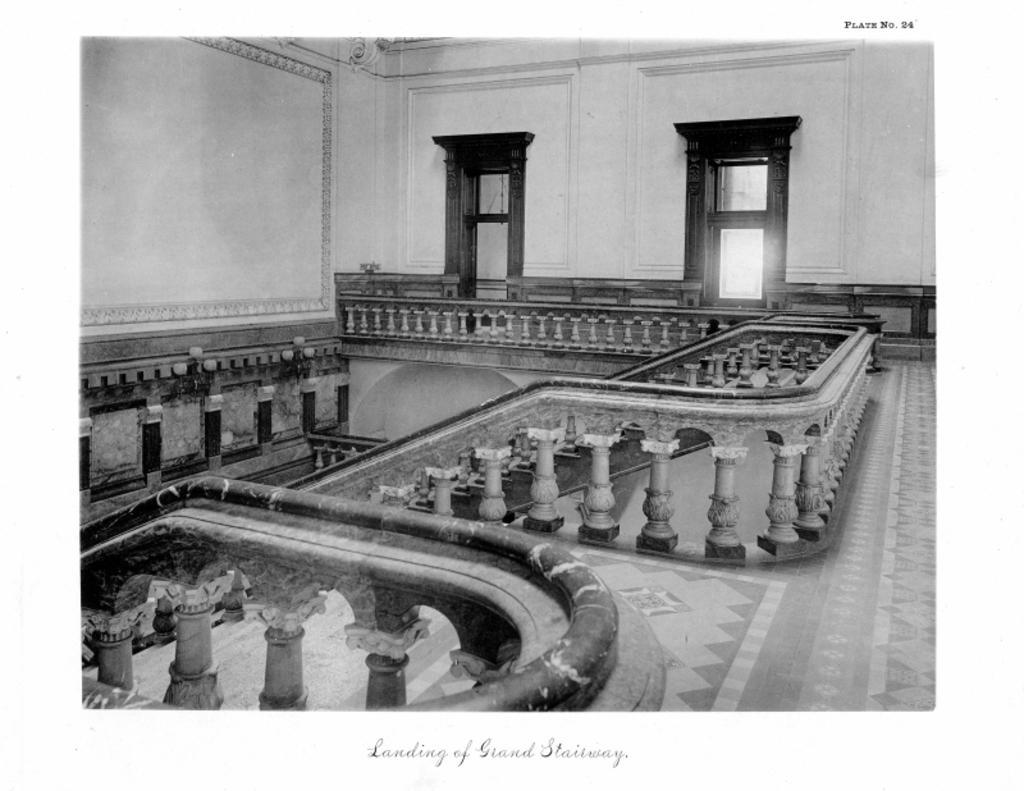In one or two sentences, can you explain what this image depicts? In this image I can see the inner part of the building. I can see the railing,doors,wall and stairs. The image is in black and white. 